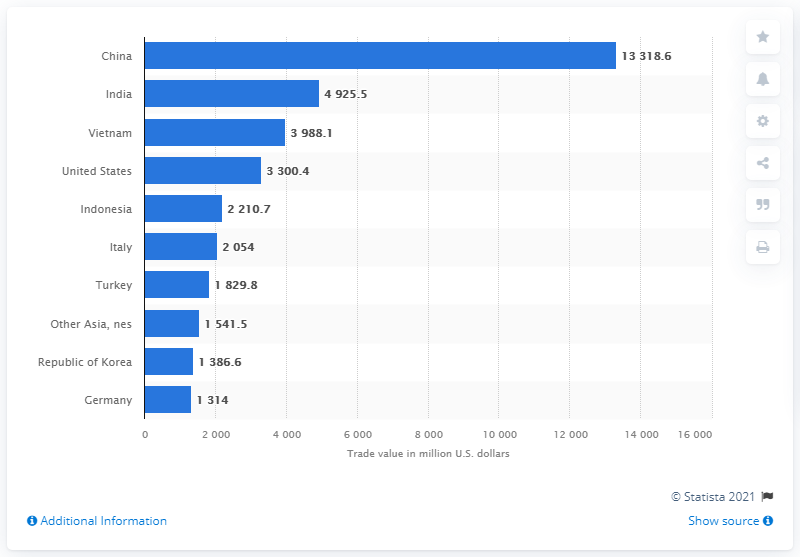Draw attention to some important aspects in this diagram. In 2019, China exported 13,318.6 metric tons of textile yarn to other countries. In 2019, the value of China's textile yarn exports in dollars was approximately 3300.4 million. 